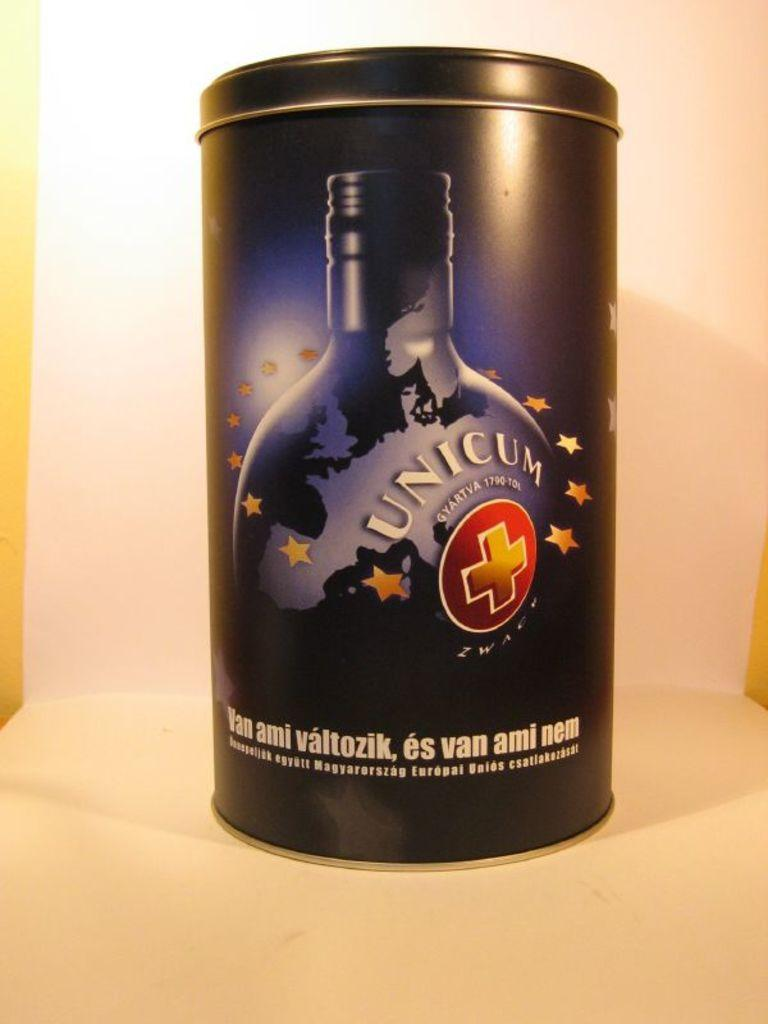<image>
Present a compact description of the photo's key features. The black Unicum liqueur case has an image of the continent of Europe on the front. 